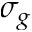<formula> <loc_0><loc_0><loc_500><loc_500>\sigma _ { g }</formula> 